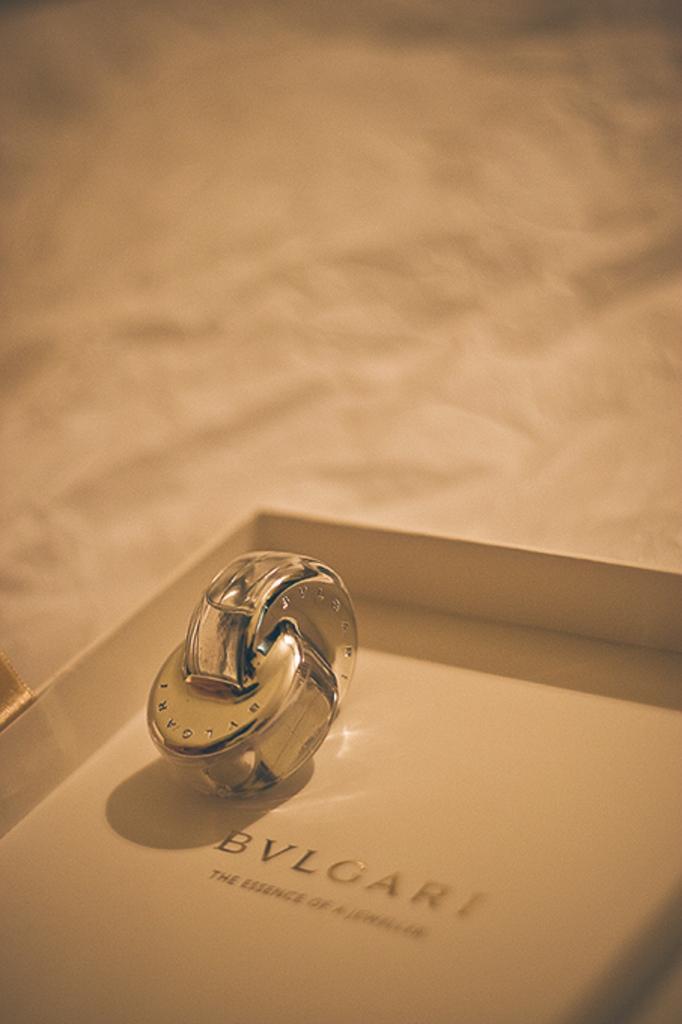How would you summarize this image in a sentence or two? In this image there is a metal object in the box which is having some text. Background is blurry. 